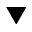<formula> <loc_0><loc_0><loc_500><loc_500>\blacktriangledown</formula> 